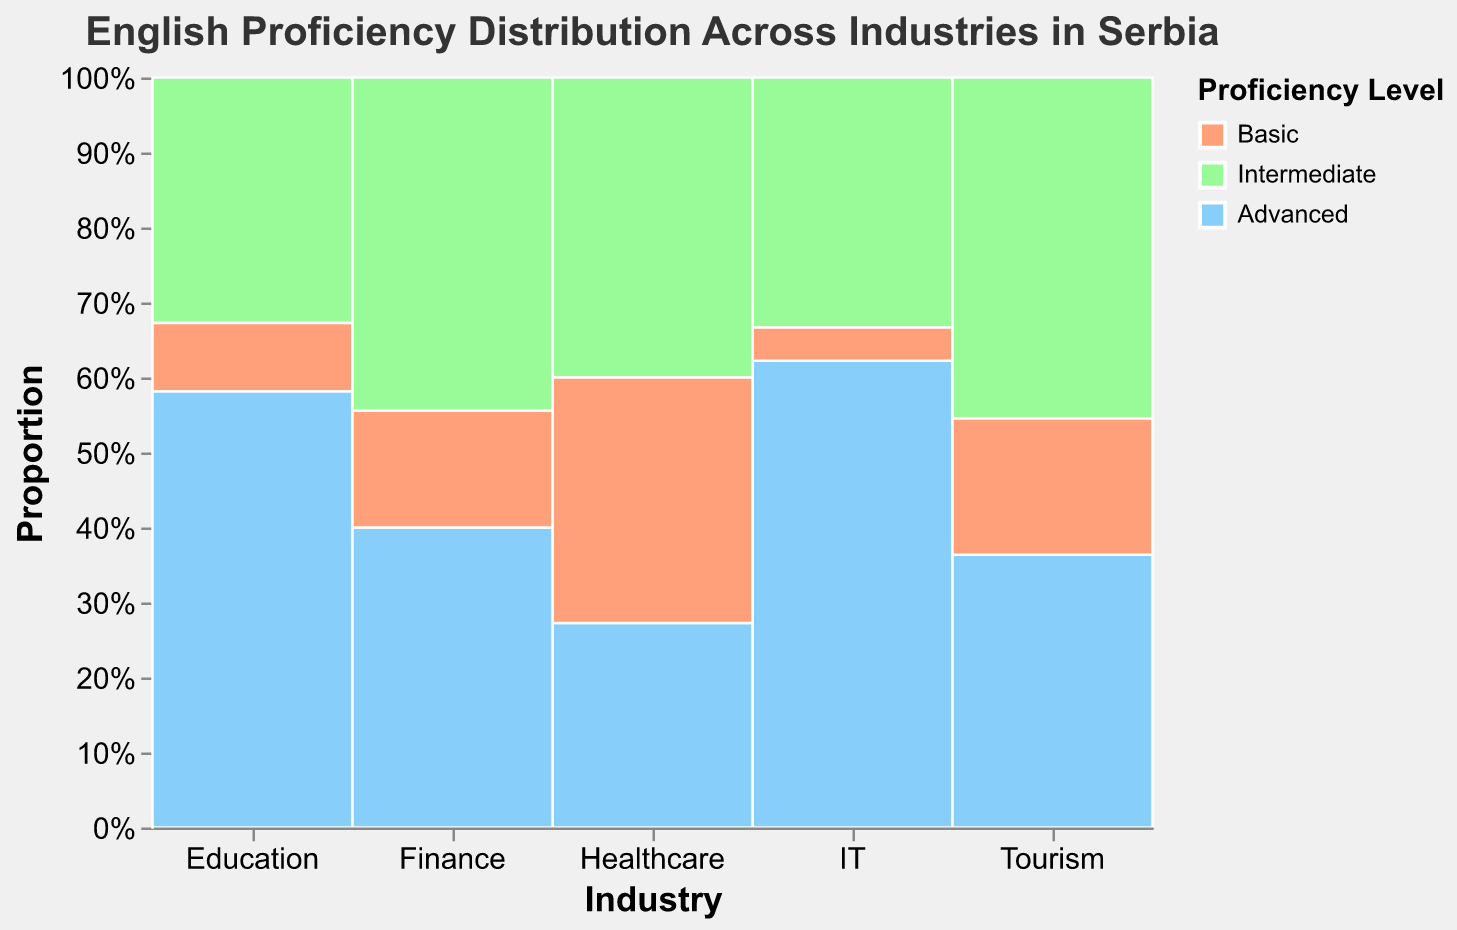What's the title of the figure? The title is usually displayed at the top of the figure. It provides a summary of what the plot is about.
Answer: "English Proficiency Distribution Across Industries in Serbia" How many proficiency levels are represented in the figure? By looking at the legend, we can see the different color codes representing proficiency levels.
Answer: Three Which industry has the highest proportion of advanced English proficiency? Looking at the height of the sections representing 'Advanced' in each industry and comparing them.
Answer: Education What percentage of the Tourism industry has basic proficiency? Hovering over the 'Basic' section in the Tourism industry provides the exact percentage.
Answer: 20% How does the proportion of Intermediate proficiency in Healthcare compare to IT? By visually comparing the heights of the 'Intermediate' sections in both Healthcare and IT.
Answer: Healthcare has a higher proportion Which industry has the smallest percentage of Basic proficiency? By identifying the smallest 'Basic' section in any of the industries.
Answer: IT What is the combined percentage of Intermediate and Basic proficiency in the Finance industry? Adding the percentages of Intermediate and Basic proficiency in the Finance industry, which can be seen by hovering over those sections.
Answer: 72% How many industries display a higher proportion of Intermediate proficiency than Basic proficiency? Counting the industries where the 'Intermediate' section is larger than the 'Basic' section.
Answer: Four Is there an industry where the proportions of Advanced and Intermediate proficiencies are almost equal? Comparing the heights of the 'Advanced' and 'Intermediate' sections across all industries.
Answer: Finance Which industry has a more even distribution across all proficiency levels? Looking for an industry where the sections for 'Basic,' 'Intermediate,' and 'Advanced' are more balanced in height.
Answer: Tourism 